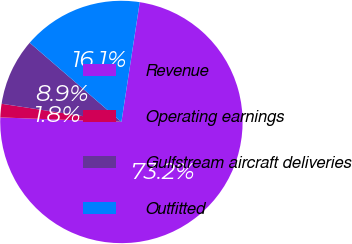Convert chart. <chart><loc_0><loc_0><loc_500><loc_500><pie_chart><fcel>Revenue<fcel>Operating earnings<fcel>Gulfstream aircraft deliveries<fcel>Outfitted<nl><fcel>73.19%<fcel>1.8%<fcel>8.94%<fcel>16.08%<nl></chart> 